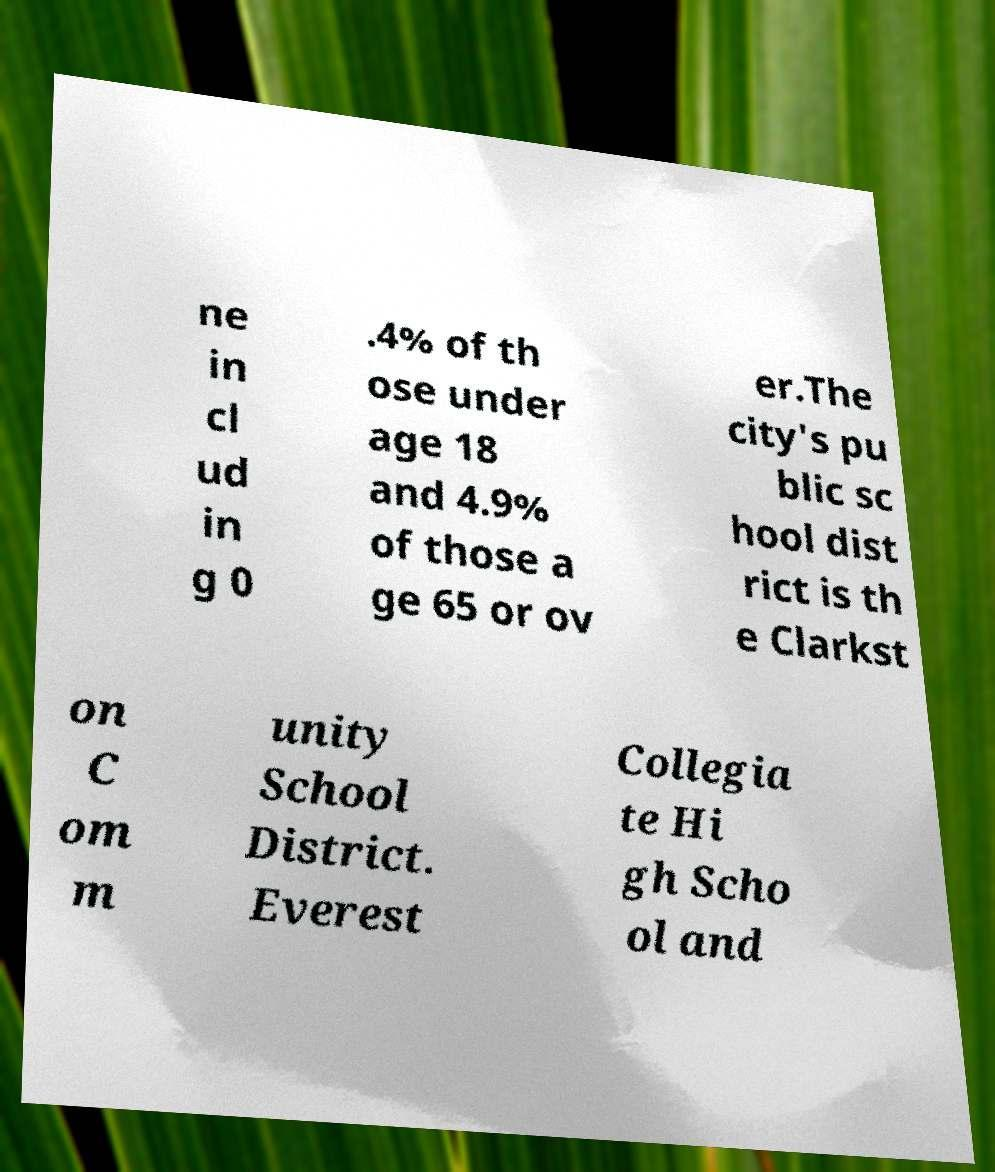I need the written content from this picture converted into text. Can you do that? ne in cl ud in g 0 .4% of th ose under age 18 and 4.9% of those a ge 65 or ov er.The city's pu blic sc hool dist rict is th e Clarkst on C om m unity School District. Everest Collegia te Hi gh Scho ol and 